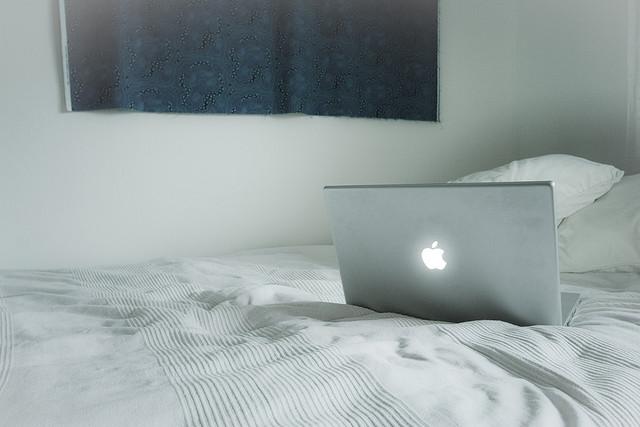What color are the curtains?
Concise answer only. Blue. Is the computer turned on?
Concise answer only. Yes. Are flowers visible?
Concise answer only. No. What brand of computer is this?
Concise answer only. Apple. Is there something to sit on?
Short answer required. Yes. 